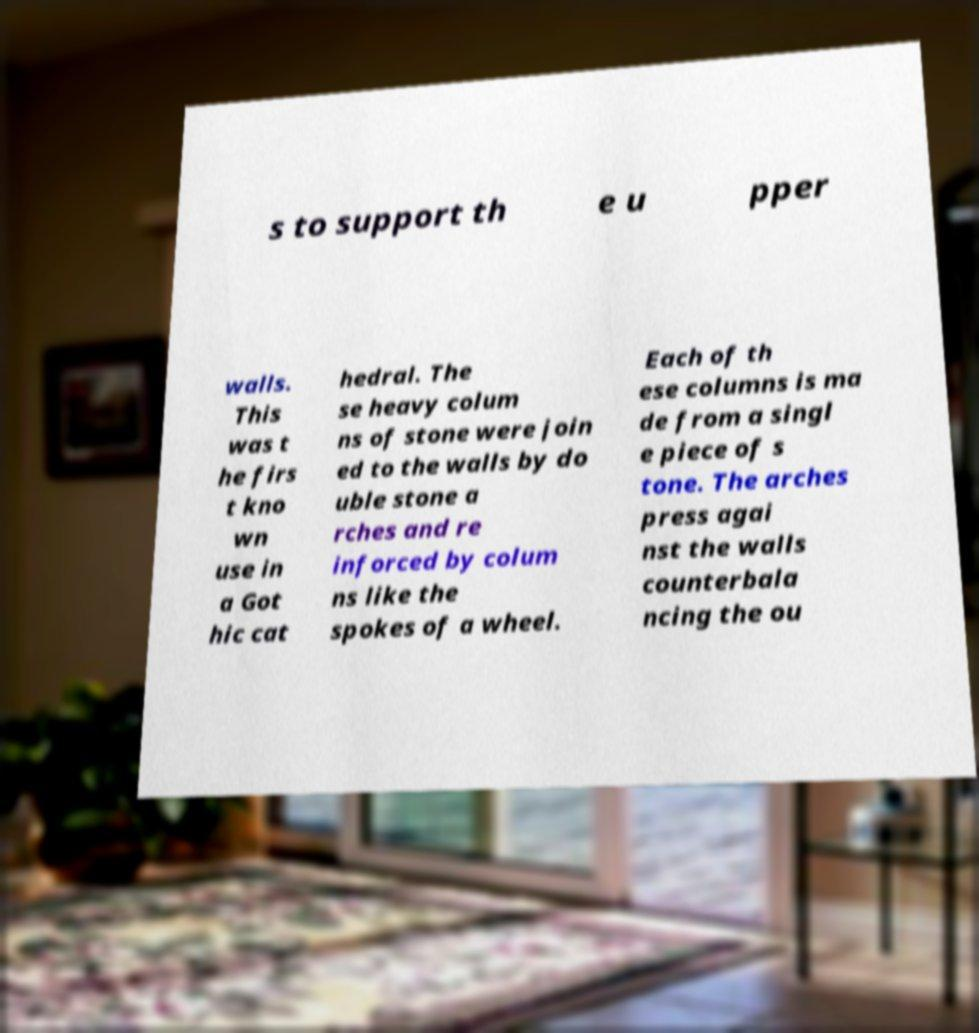Can you read and provide the text displayed in the image?This photo seems to have some interesting text. Can you extract and type it out for me? s to support th e u pper walls. This was t he firs t kno wn use in a Got hic cat hedral. The se heavy colum ns of stone were join ed to the walls by do uble stone a rches and re inforced by colum ns like the spokes of a wheel. Each of th ese columns is ma de from a singl e piece of s tone. The arches press agai nst the walls counterbala ncing the ou 